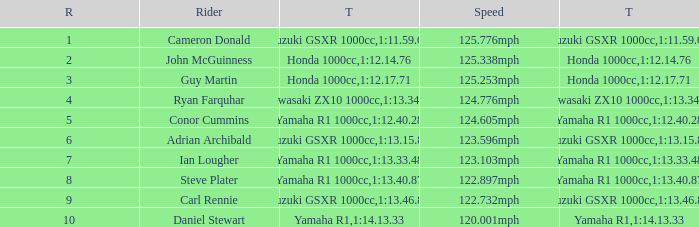What time did team kawasaki zx10 1000cc have? 1:13.34.98. 